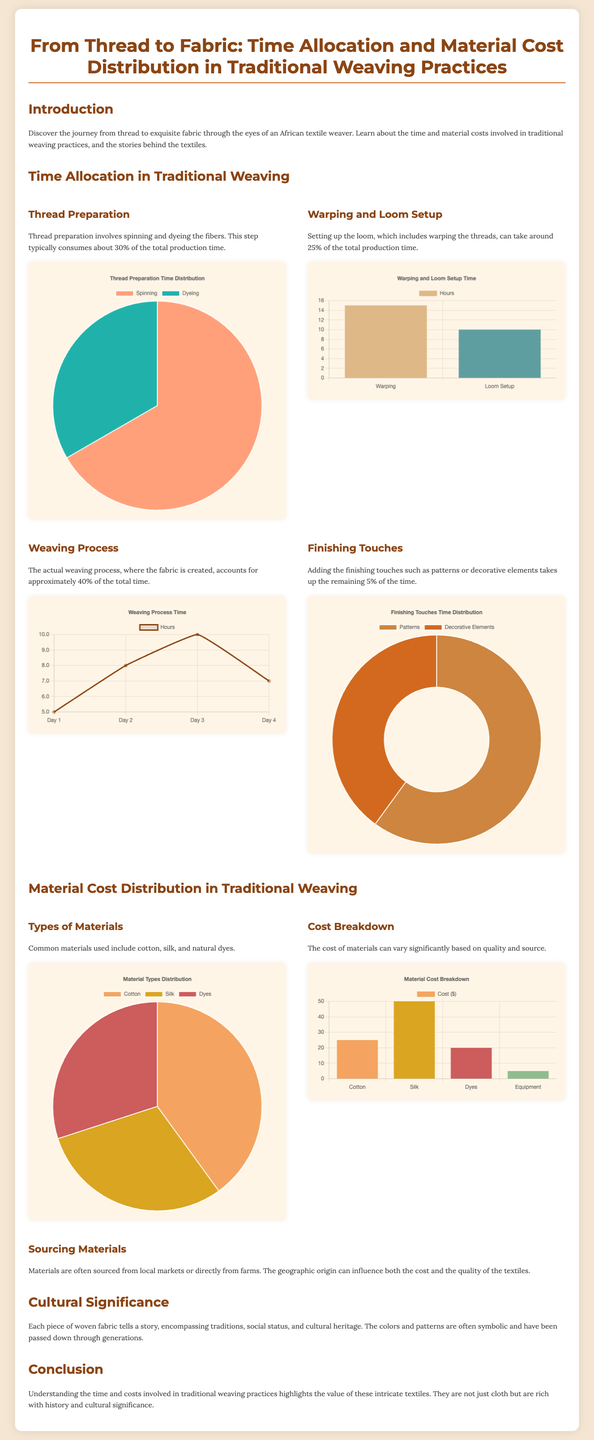What percentage of total production time is spent on thread preparation? The document states that thread preparation consumes about 30% of the total production time.
Answer: 30% How many days are recorded for the weaving process? The weaving process chart lists the time across four days.
Answer: 4 What is the primary material used in traditional weaving? The material types distribution chart indicates that cotton is the primary material, accounting for 40%.
Answer: Cotton What percentage of time is allocated to finishing touches? The chart notes that finishing touches take up 5% of the total production time.
Answer: 5% What is the cost of silk in the material cost breakdown? The cost breakdown chart specifies that the cost of silk is $50.
Answer: 50 What is the total time allocated for weaving in the process chart? The total time over the four days of the weaving process is the sum of hours which equals 30 hours.
Answer: 30 How many hours are spent on warping during loom setup? The loom setup chart indicates that warping takes 15 hours.
Answer: 15 Which decorative element takes more time in the finishing touches? The finishing touches time distribution shows patterns take more time than decorative elements, with 3 hours for patterns.
Answer: Patterns What is the combined cost of dyes and equipment? The cost breakdown shows dyes cost $20 and equipment costs $5, summing up to $25.
Answer: 25 